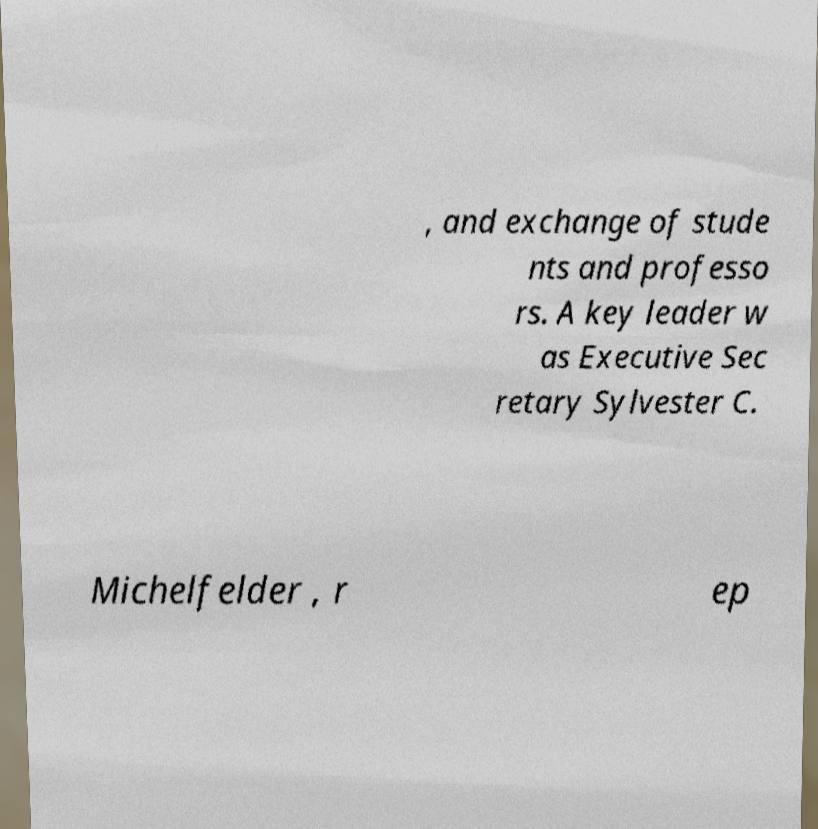There's text embedded in this image that I need extracted. Can you transcribe it verbatim? , and exchange of stude nts and professo rs. A key leader w as Executive Sec retary Sylvester C. Michelfelder , r ep 